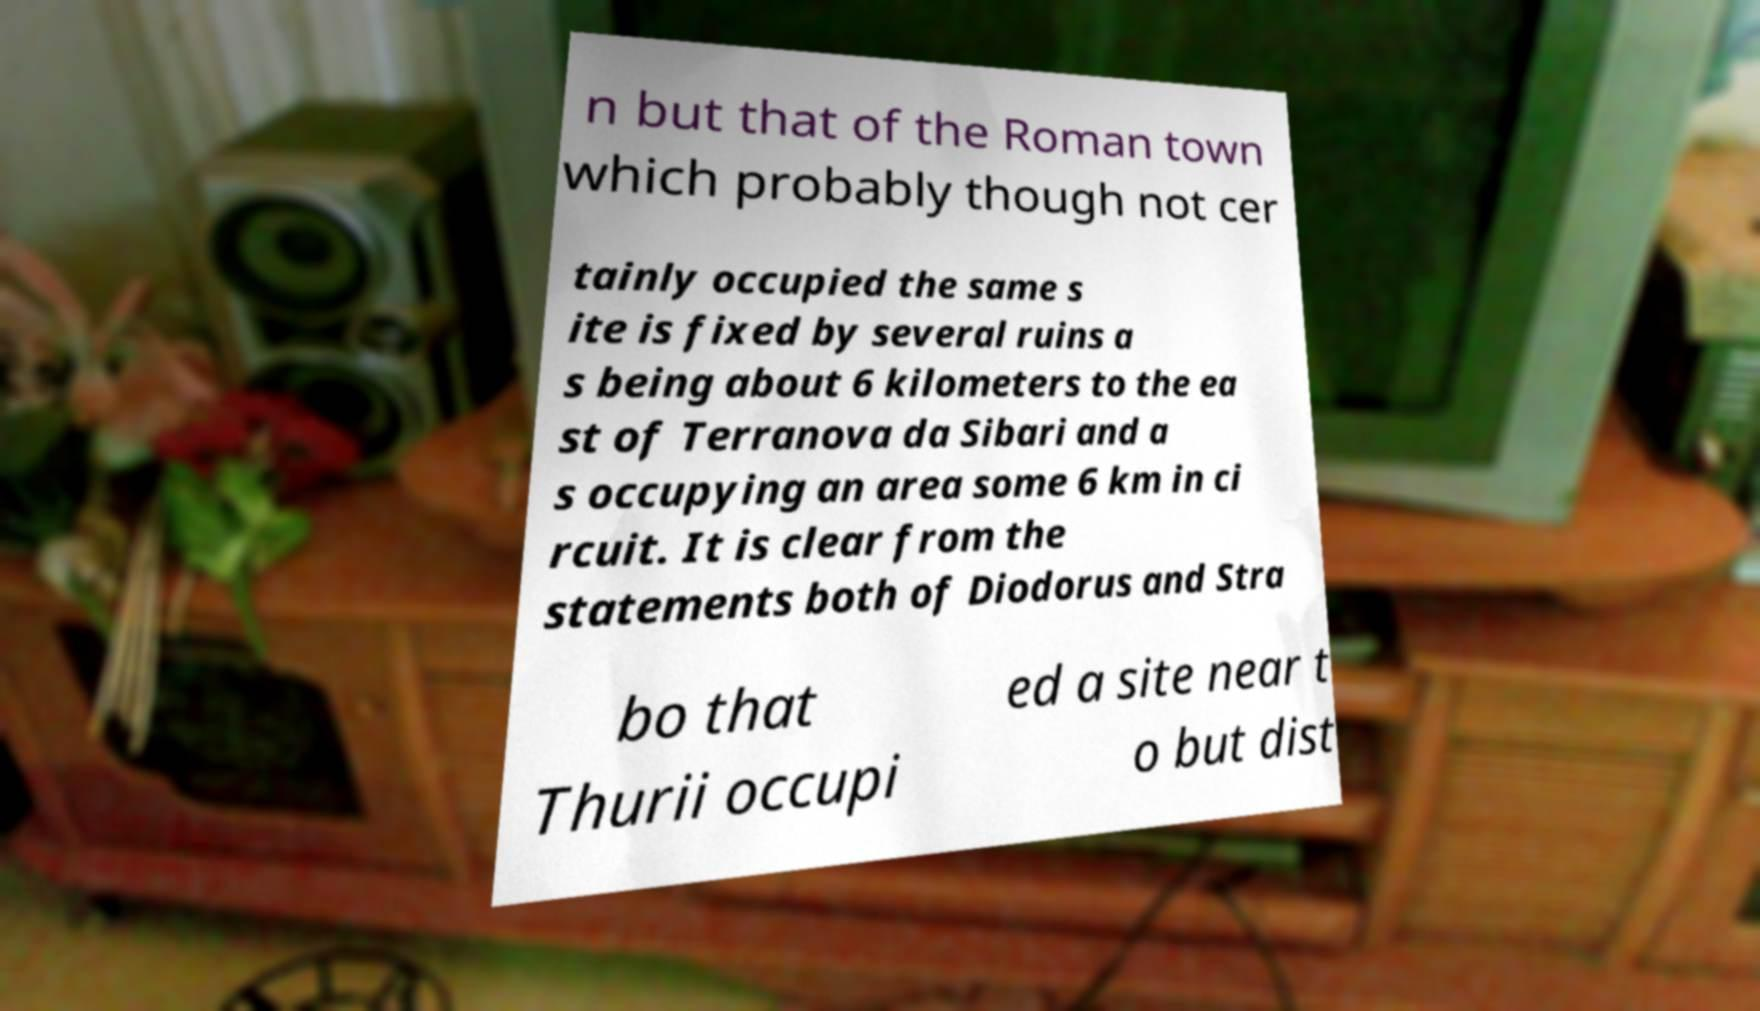Could you extract and type out the text from this image? n but that of the Roman town which probably though not cer tainly occupied the same s ite is fixed by several ruins a s being about 6 kilometers to the ea st of Terranova da Sibari and a s occupying an area some 6 km in ci rcuit. It is clear from the statements both of Diodorus and Stra bo that Thurii occupi ed a site near t o but dist 